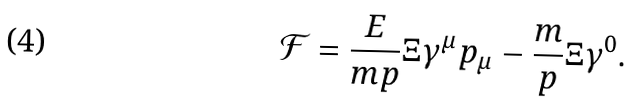<formula> <loc_0><loc_0><loc_500><loc_500>\mathcal { F } = \frac { E } { m p } \Xi \gamma ^ { \mu } p _ { \mu } - \frac { m } { p } \Xi \gamma ^ { 0 } .</formula> 